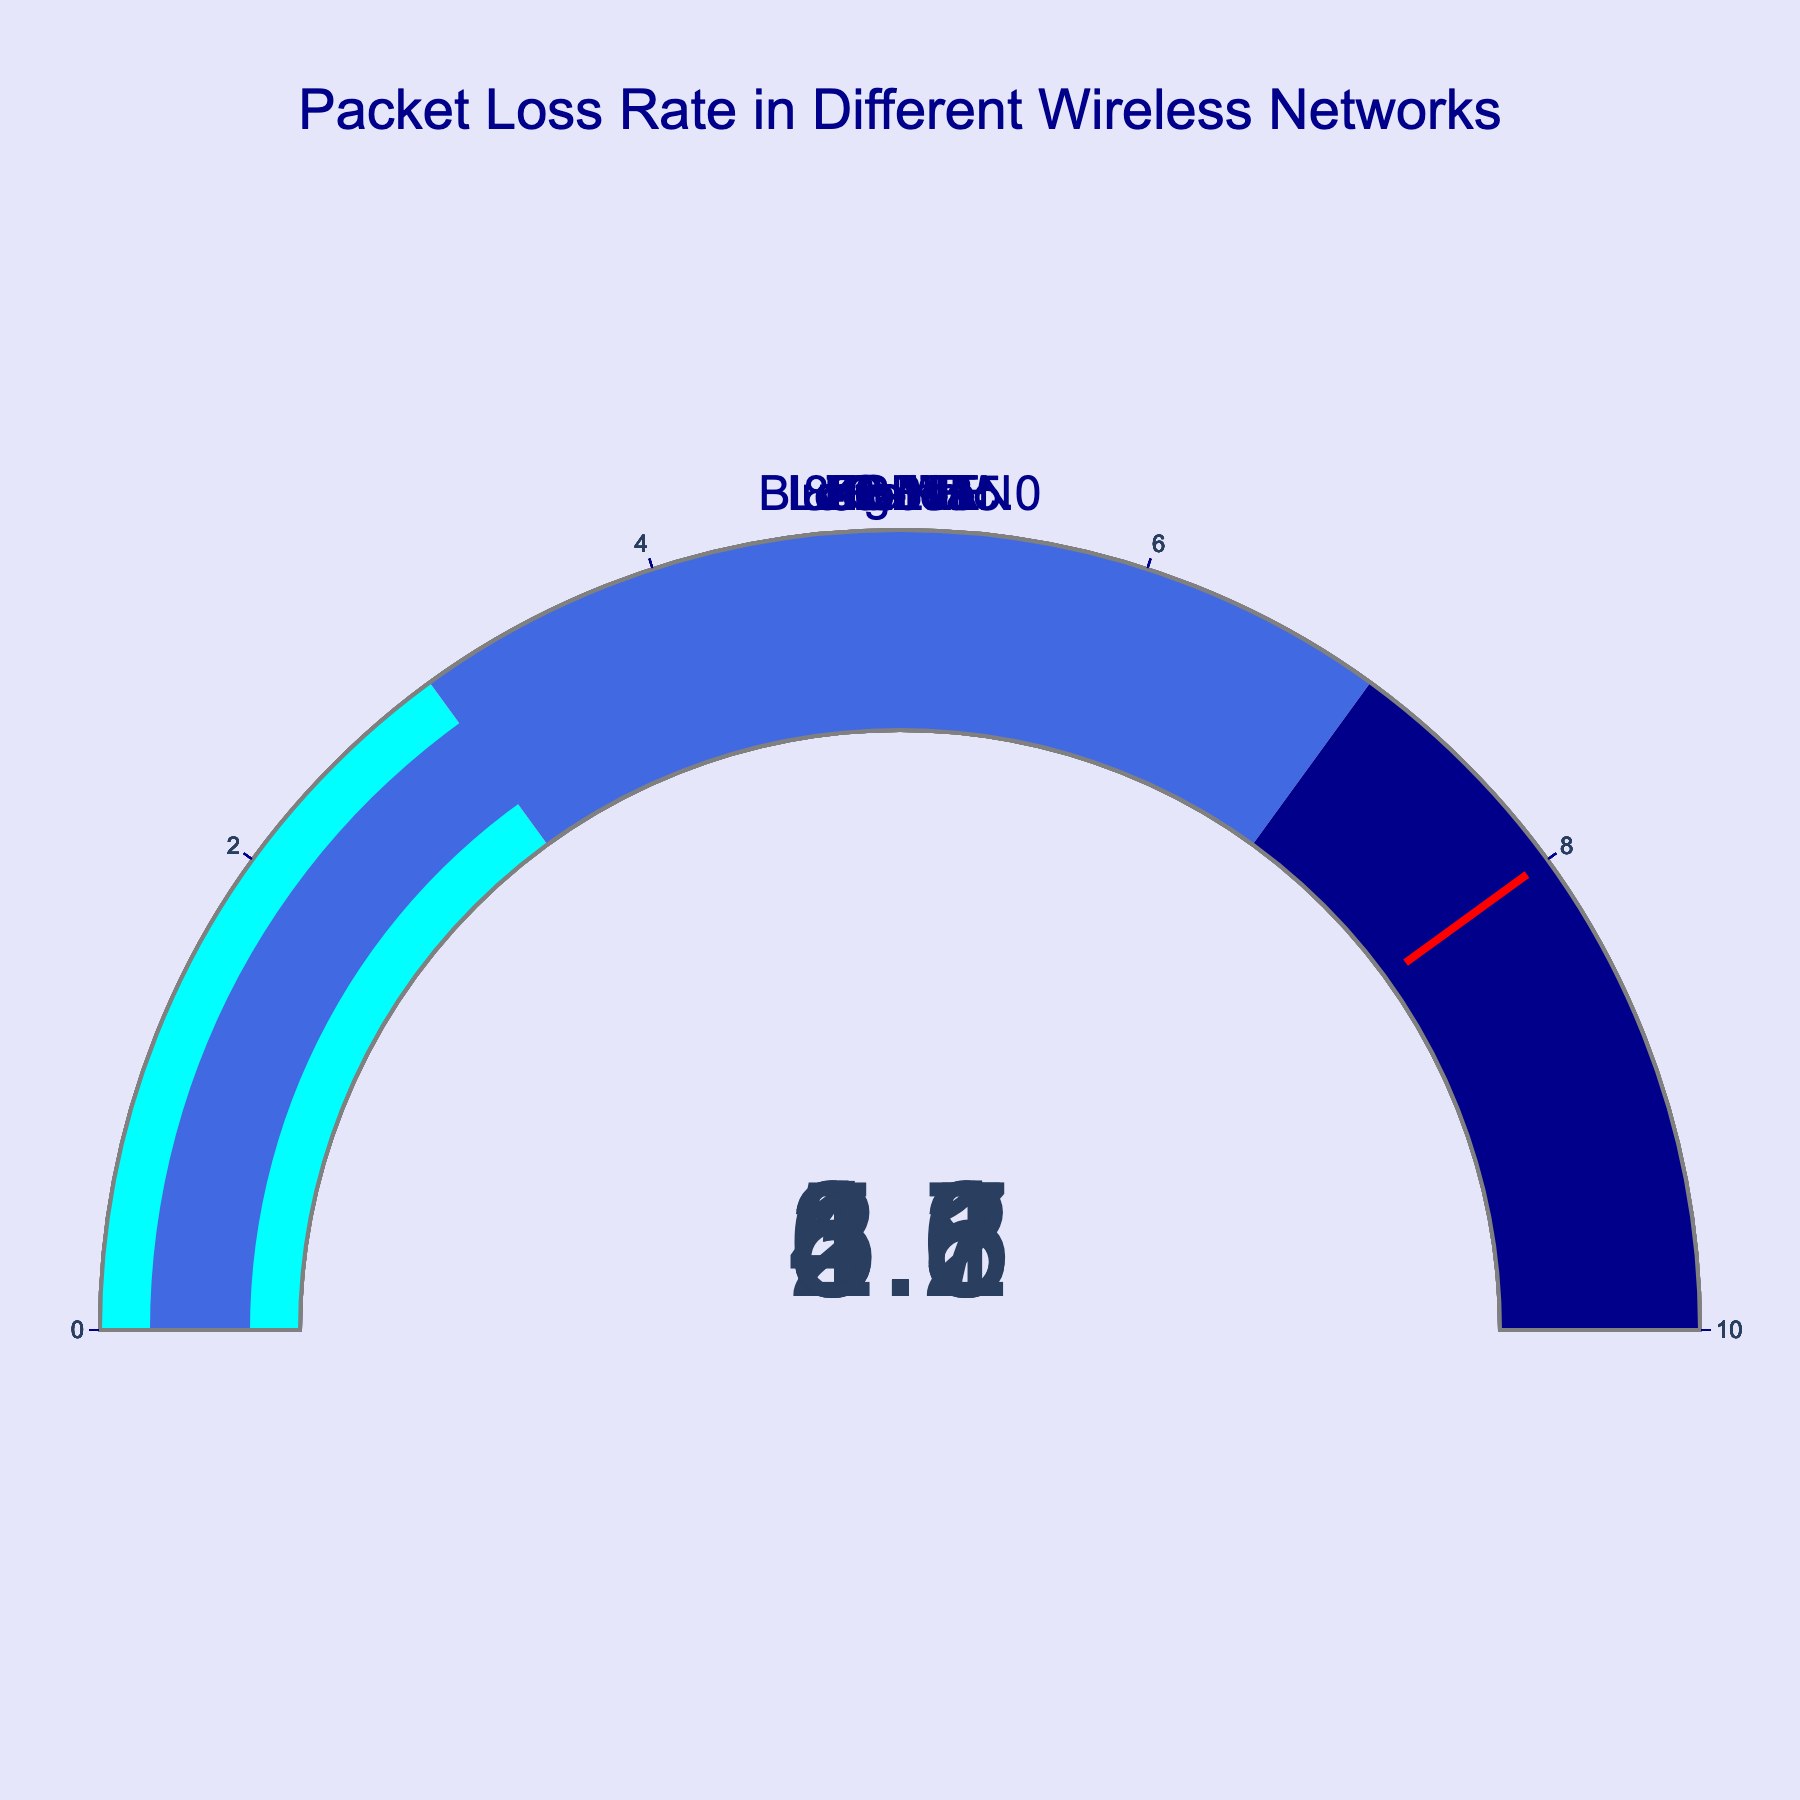What is the packet loss rate for 5G NR? The gauge for 5G NR shows a value of 1.5.
Answer: 1.5 Which network has the highest packet loss rate? By comparing all the gauges, NB-IoT shows the highest packet loss rate with a value of 6.7.
Answer: NB-IoT How does the packet loss rate of Bluetooth 5.0 compare to ZigBee? The packet loss rate for Bluetooth 5.0 is 4.1, while for ZigBee, it is 3.6. Bluetooth 5.0 has a higher packet loss rate.
Answer: Bluetooth 5.0 has a higher packet loss rate What is the total packet loss rate for 802.11ac and 4G LTE combined? The packet loss rate for 802.11ac is 2.3 and for 4G LTE is 3.8. Adding these values: 2.3 + 3.8 = 6.1.
Answer: 6.1 If the threshold value is 8, which networks stay below this value? Comparing all gauges to the threshold value of 8, all networks (802.11ac, 4G LTE, 5G NR, LoRaWAN, Bluetooth 5.0, ZigBee, and NB-IoT) stay below the threshold.
Answer: All networks What is the average packet loss rate for the displayed networks? Sum the packet loss rates for all networks: 2.3 + 3.8 + 1.5 + 5.2 + 4.1 + 3.6 + 6.7 = 27.2. There are 7 networks, so the average packet loss rate is 27.2 / 7 ≈ 3.89.
Answer: 3.89 Which network has the lowest packet loss rate? By comparing all the gauges, 5G NR shows the lowest packet loss rate with a value of 1.5.
Answer: 5G NR What is the range of the packet loss rates displayed in the gauges? The lowest packet loss rate is 1.5 (5G NR) and the highest is 6.7 (NB-IoT). The range is 6.7 - 1.5 = 5.2.
Answer: 5.2 Are there any networks with a packet loss rate above 5? The gauges show that LoRaWAN and NB-IoT have packet loss rates above 5, with values of 5.2 and 6.7, respectively.
Answer: Yes How much higher is the packet loss rate for NB-IoT compared to 802.11ac? The packet loss rate for NB-IoT is 6.7 and for 802.11ac is 2.3. The difference is 6.7 - 2.3 = 4.4.
Answer: 4.4 